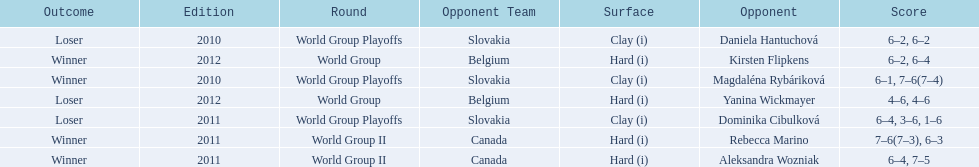What was the next game listed after the world group ii rounds? World Group Playoffs. 